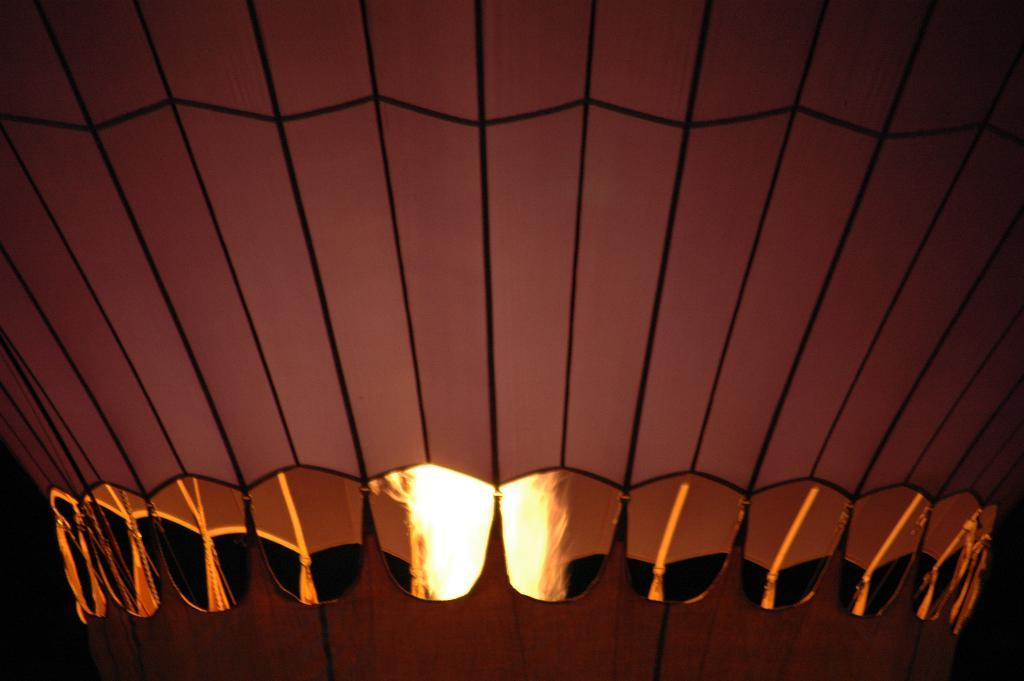What is the main object in the foreground of the image? There is a parachute in the foreground of the image. What type of acoustics can be heard coming from the desk in the image? There is no desk present in the image, so it is not possible to determine what, if any, acoustics might be heard. 